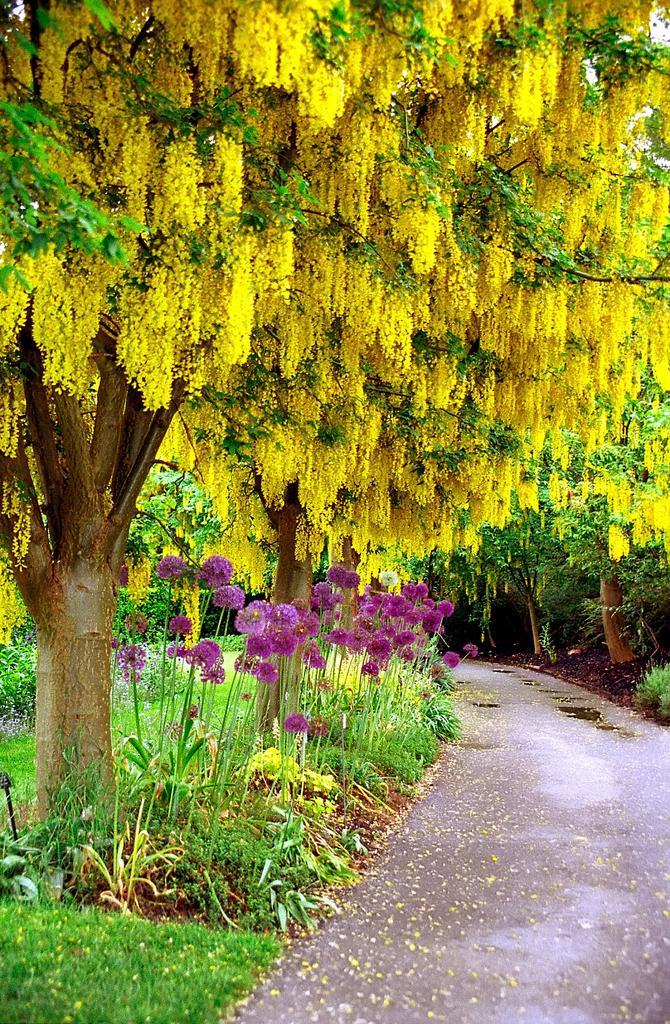How would you summarize this image in a sentence or two? In this image I can see few flowers in purple and yellow color and I can also see few trees in green color. 